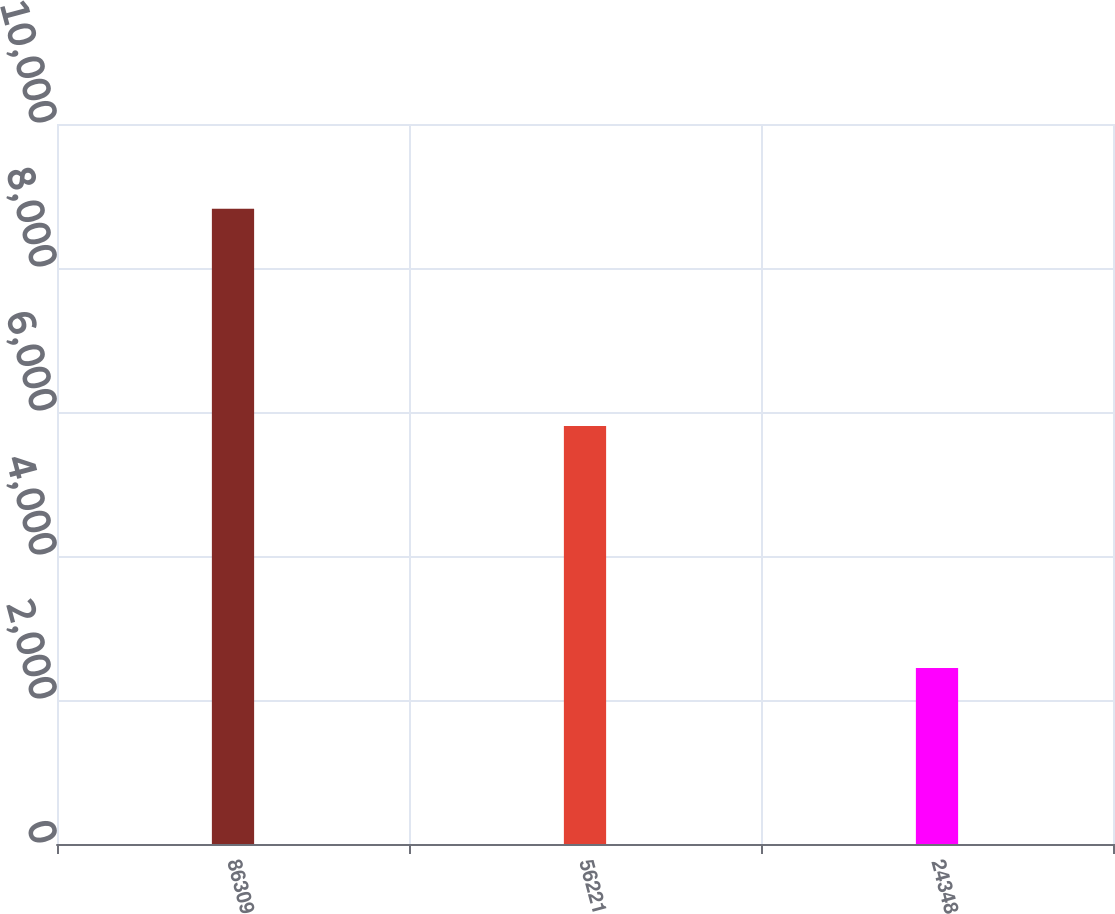Convert chart. <chart><loc_0><loc_0><loc_500><loc_500><bar_chart><fcel>86309<fcel>56221<fcel>24348<nl><fcel>8822.9<fcel>5806.4<fcel>2443.2<nl></chart> 